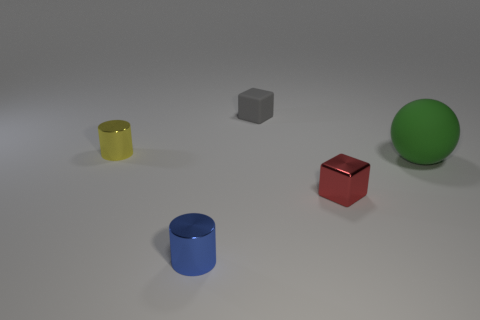Add 2 blue shiny cylinders. How many objects exist? 7 Subtract all spheres. How many objects are left? 4 Subtract all tiny gray matte things. Subtract all balls. How many objects are left? 3 Add 5 spheres. How many spheres are left? 6 Add 5 tiny yellow things. How many tiny yellow things exist? 6 Subtract 0 red cylinders. How many objects are left? 5 